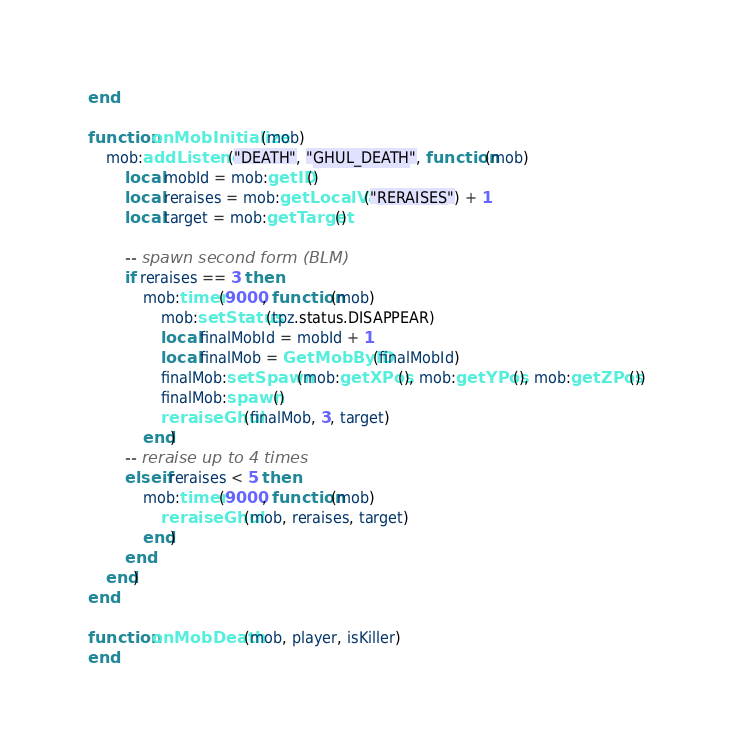<code> <loc_0><loc_0><loc_500><loc_500><_Lua_>end

function onMobInitialize(mob)
    mob:addListener("DEATH", "GHUL_DEATH", function(mob)
        local mobId = mob:getID()
        local reraises = mob:getLocalVar("RERAISES") + 1
        local target = mob:getTarget()

        -- spawn second form (BLM)
        if reraises == 3 then
            mob:timer(9000, function(mob)
                mob:setStatus(tpz.status.DISAPPEAR)
                local finalMobId = mobId + 1
                local finalMob = GetMobByID(finalMobId)
                finalMob:setSpawn(mob:getXPos(), mob:getYPos(), mob:getZPos())
                finalMob:spawn()
                reraiseGhul(finalMob, 3, target)
            end)
        -- reraise up to 4 times
        elseif reraises < 5 then
            mob:timer(9000, function(mob)
                reraiseGhul(mob, reraises, target)
            end)
        end
    end)
end

function onMobDeath(mob, player, isKiller)
end
</code> 